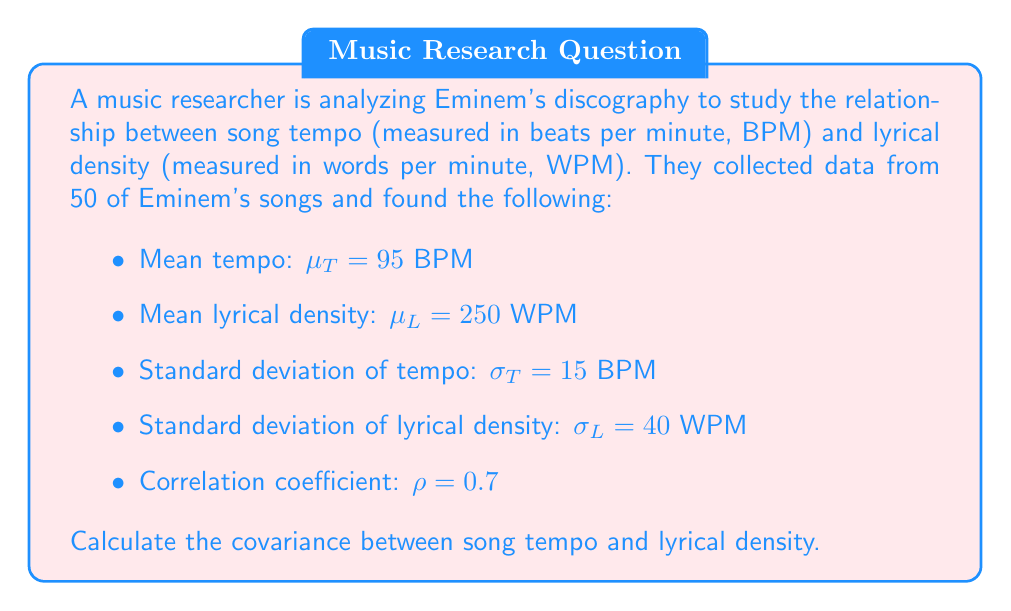Give your solution to this math problem. To solve this problem, we'll use the formula for covariance given the correlation coefficient and standard deviations:

$$\text{Cov}(X,Y) = \rho \cdot \sigma_X \cdot \sigma_Y$$

Where:
- $\rho$ is the correlation coefficient
- $\sigma_X$ is the standard deviation of X (tempo in this case)
- $\sigma_Y$ is the standard deviation of Y (lyrical density in this case)

Let's substitute the given values:

$\rho = 0.7$
$\sigma_T = 15$ BPM
$\sigma_L = 40$ WPM

Now, let's calculate:

$$\begin{align}
\text{Cov}(T,L) &= \rho \cdot \sigma_T \cdot \sigma_L \\
&= 0.7 \cdot 15 \cdot 40 \\
&= 0.7 \cdot 600 \\
&= 420
\end{align}$$

The units of covariance are the product of the units of the two variables, so in this case, it's BPM · WPM.
Answer: 420 BPM · WPM 